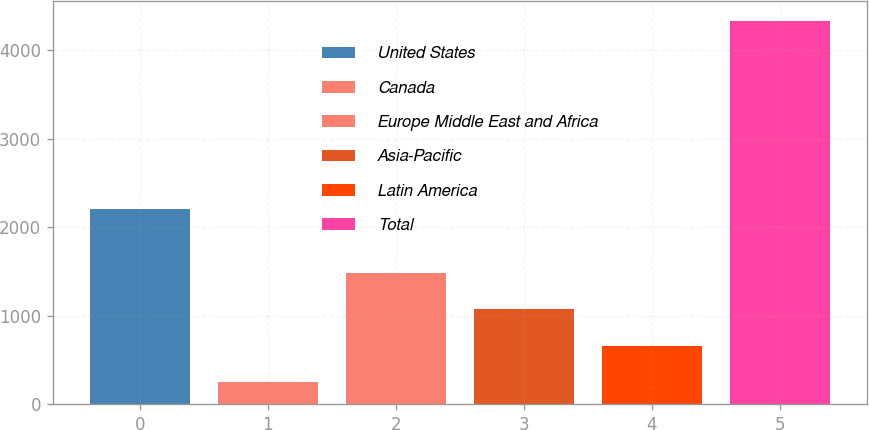Convert chart. <chart><loc_0><loc_0><loc_500><loc_500><bar_chart><fcel>United States<fcel>Canada<fcel>Europe Middle East and Africa<fcel>Asia-Pacific<fcel>Latin America<fcel>Total<nl><fcel>2209.2<fcel>257.1<fcel>1479.72<fcel>1072.18<fcel>664.64<fcel>4332.5<nl></chart> 